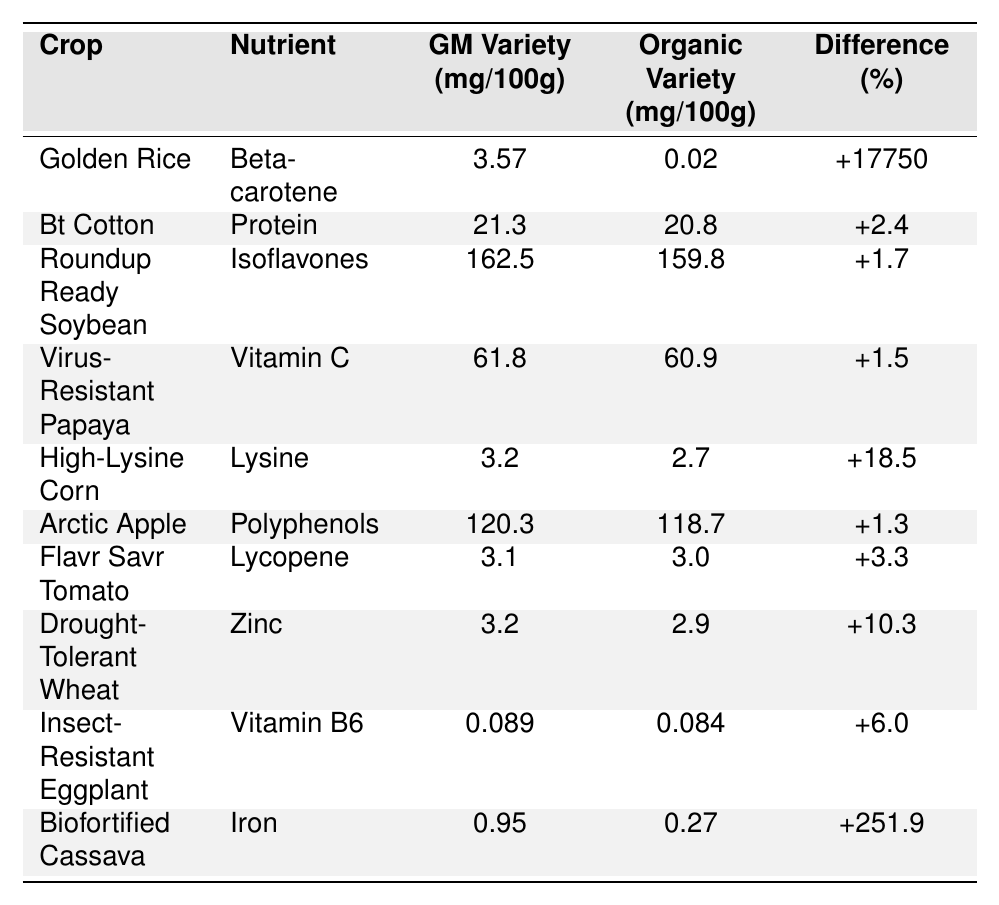What is the nutrient content of Golden Rice for Beta-carotene? The table shows that the GM variety of Golden Rice contains 3.57 mg/100g of Beta-carotene.
Answer: 3.57 mg/100g Which crop has the highest difference in nutrient content between GM and organic varieties? Looking through the table, Biofortified Cassava has the highest difference of +251.9% between its GM and organic varieties.
Answer: Biofortified Cassava Is the protein content higher in Bt Cotton or Roundup Ready Soybean? The GM variety of Bt Cotton has 21.3 mg/100g and Roundup Ready Soybean has 162.5 mg/100g of Isoflavones protein, so Bt Cotton has a higher protein content.
Answer: Bt Cotton What is the percentage difference in Vitamin C between Virus-Resistant Papaya and its organic counterpart? The table indicates a percentage difference of +1.5% in Vitamin C for Virus-Resistant Papaya between the GM variety and the organic variety.
Answer: +1.5% Calculate the average difference percentage for the listed crops. The differences are: +17750, +2.4, +1.7, +1.5, +18.5, +1.3, +3.3, +10.3, +6.0, +251.9. Adding these up gives 18043.2, dividing by 10 gives an average of 1804.32%.
Answer: 1804.32% Does High-Lysine Corn provide a higher lysine content than Organic variety? Yes, High-Lysine Corn's GM variety contains 3.2 mg/100g, which is higher than the organic variety's 2.7 mg/100g.
Answer: Yes In terms of PM content, how does the Arctic Apple compare to the organic variant? The Arctic Apple contains 120.3 mg/100g of polyphenols, while the organic variant contains 118.7 mg/100g; thus, the GM variant has a higher polyphenol content.
Answer: Higher Which nutrient in Biofortified Cassava shows the most significant increase in the GM variety? The nutrient in Biofortified Cassava showing the most significant increase is Iron, with a difference percentage of +251.9%.
Answer: Iron What is the GM variety's vitamin B6 content in Insect-Resistant Eggplant? The GM variety of Insect-Resistant Eggplant has a vitamin B6 content of 0.089 mg/100g.
Answer: 0.089 mg/100g Is the difference in nutrient content for Flavr Savr Tomato greater than 5%? The difference is +3.3%, which is not greater than 5%.
Answer: No 